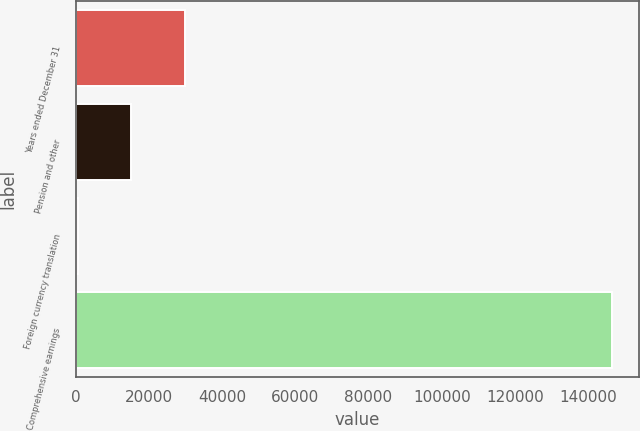Convert chart to OTSL. <chart><loc_0><loc_0><loc_500><loc_500><bar_chart><fcel>Years ended December 31<fcel>Pension and other<fcel>Foreign currency translation<fcel>Comprehensive earnings<nl><fcel>29773.4<fcel>15187.7<fcel>602<fcel>146459<nl></chart> 